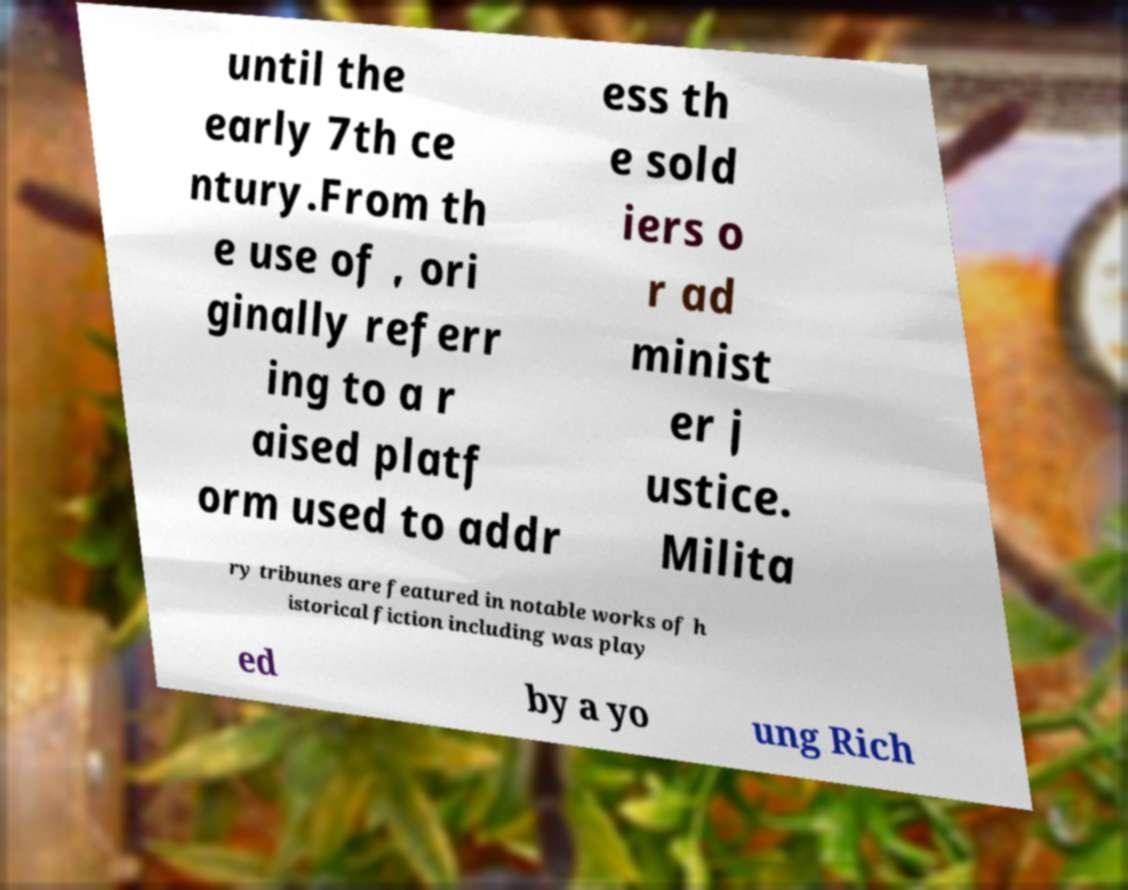Could you extract and type out the text from this image? until the early 7th ce ntury.From th e use of , ori ginally referr ing to a r aised platf orm used to addr ess th e sold iers o r ad minist er j ustice. Milita ry tribunes are featured in notable works of h istorical fiction including was play ed by a yo ung Rich 